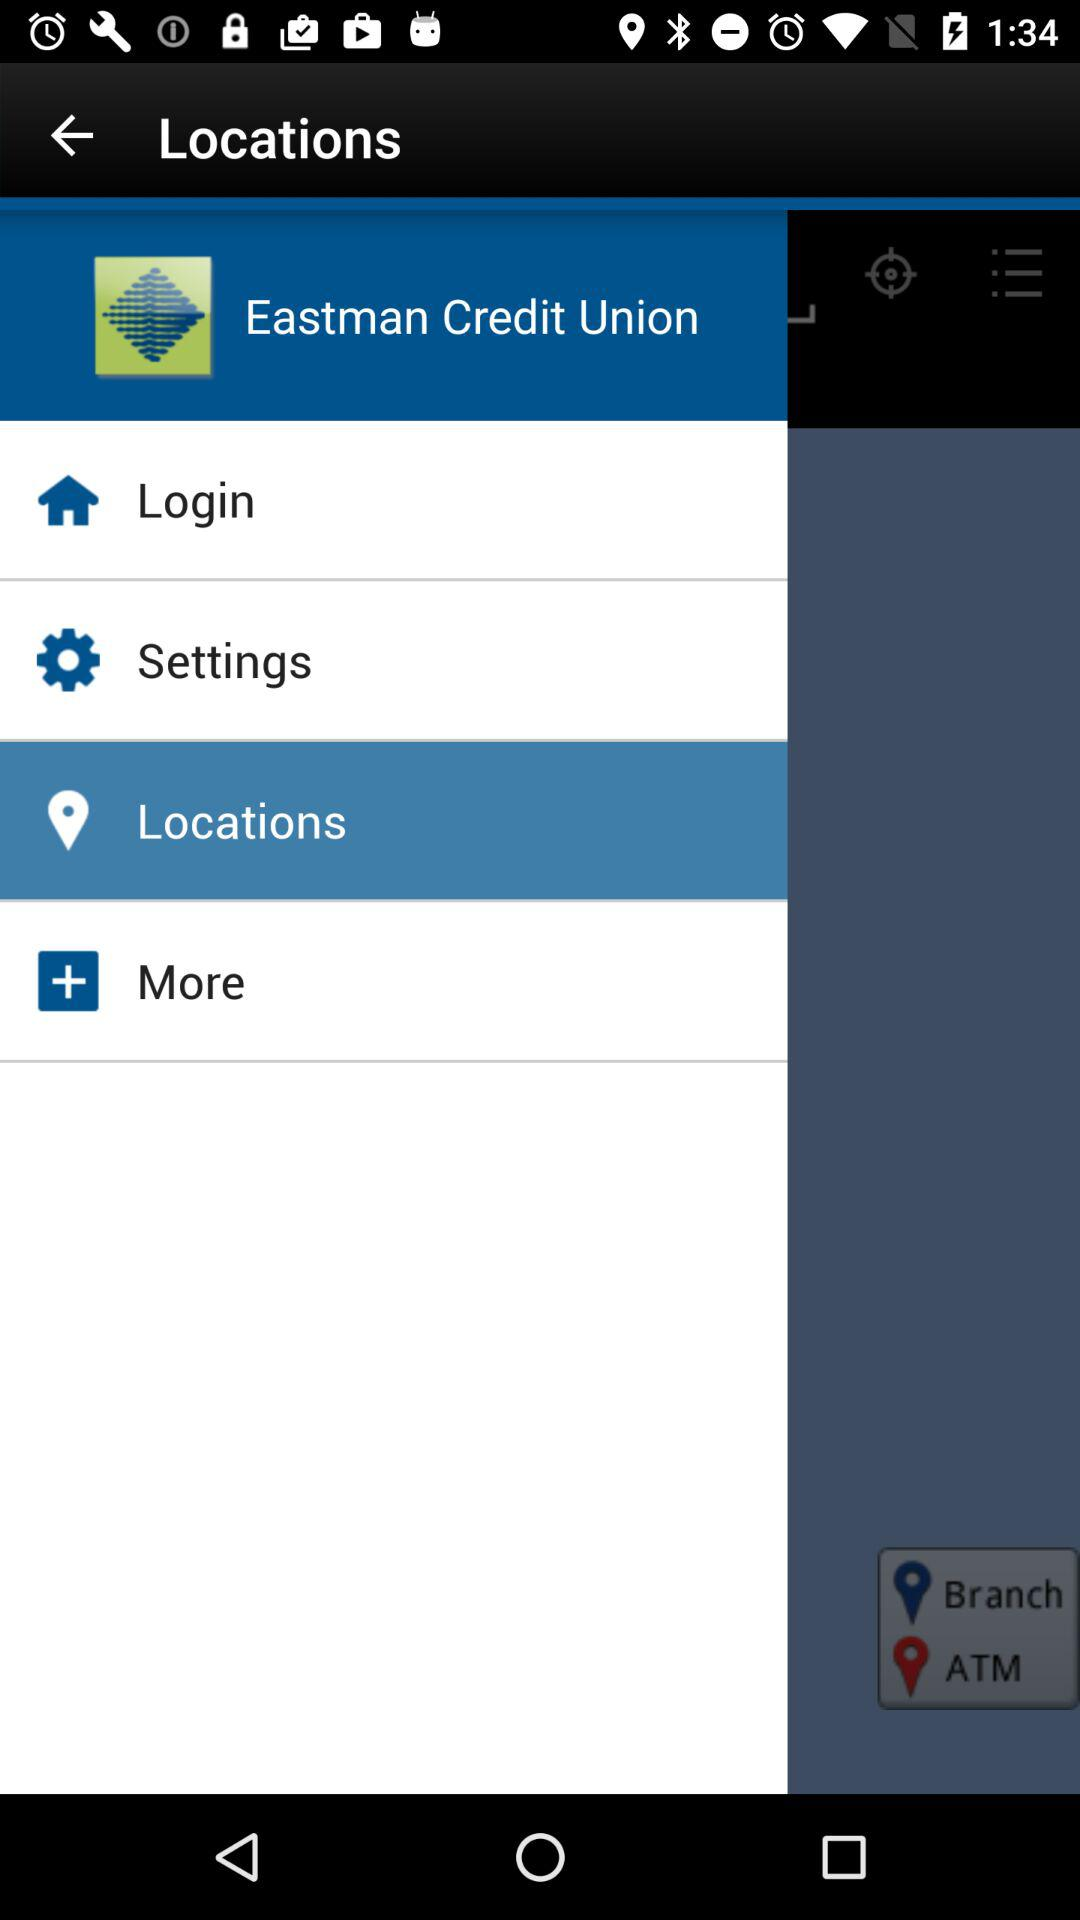What is the selected option? The selected option is "Locations". 